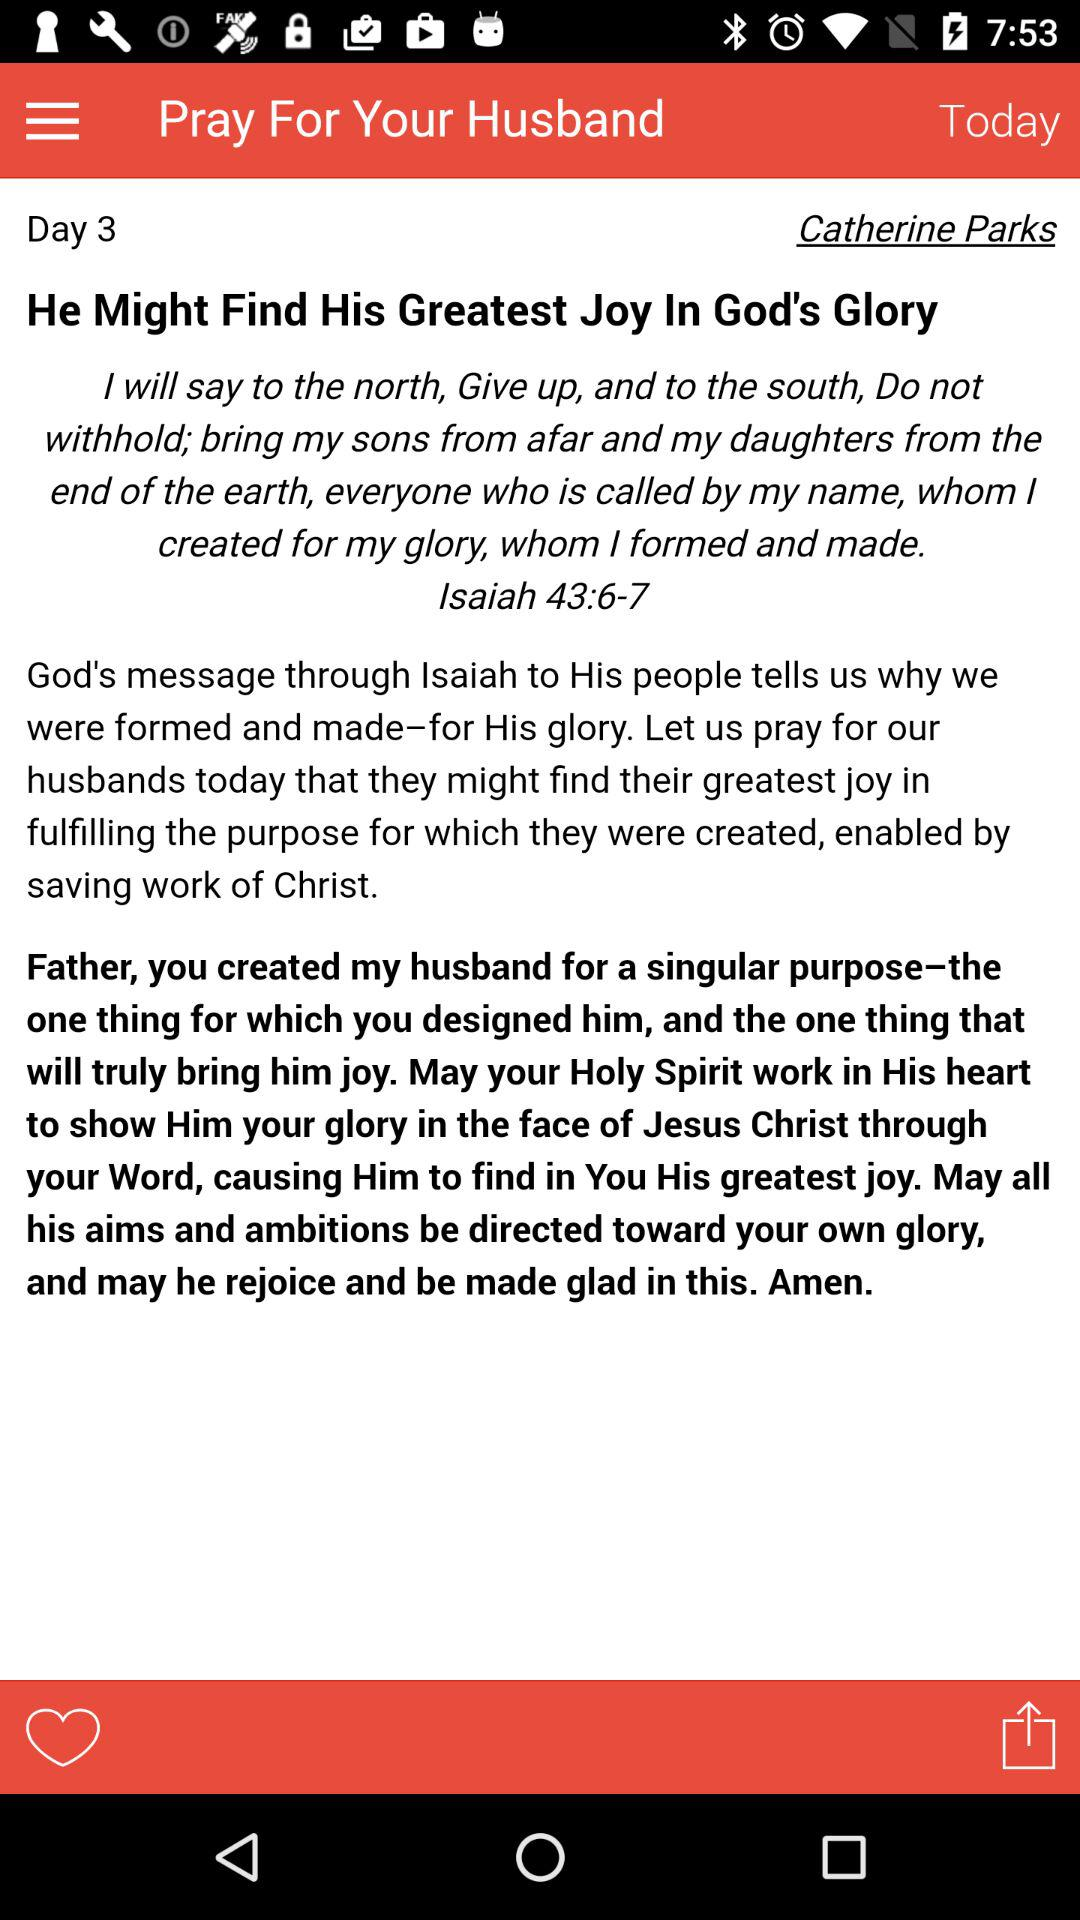Which day is shown? The shown day is 3. 